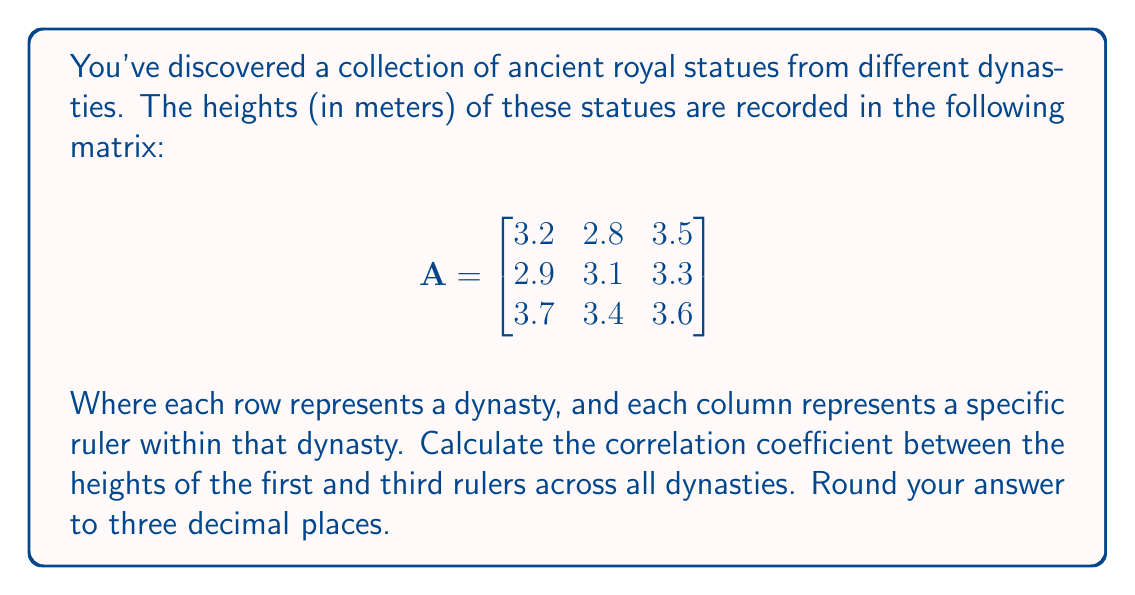Provide a solution to this math problem. To calculate the correlation coefficient between the heights of the first and third rulers, we'll follow these steps:

1) First, we need to extract the relevant columns from the matrix:

   First ruler (x): $[3.2, 2.9, 3.7]$
   Third ruler (y): $[3.5, 3.3, 3.6]$

2) Calculate the means:
   
   $\bar{x} = \frac{3.2 + 2.9 + 3.7}{3} = 3.267$
   $\bar{y} = \frac{3.5 + 3.3 + 3.6}{3} = 3.467$

3) Calculate the deviations from the mean:

   $x - \bar{x}: [-0.067, -0.367, 0.433]$
   $y - \bar{y}: [0.033, -0.167, 0.133]$

4) Calculate the products of the deviations:

   $(x - \bar{x})(y - \bar{y}): [-0.002211, 0.061289, 0.057589]$

5) Sum these products to get the covariance:

   $\text{cov}(x,y) = \frac{1}{n-1}\sum(x - \bar{x})(y - \bar{y}) = \frac{-0.002211 + 0.061289 + 0.057589}{2} = 0.0583335$

6) Calculate the standard deviations:

   $s_x = \sqrt{\frac{1}{n-1}\sum(x - \bar{x})^2} = \sqrt{\frac{(-0.067)^2 + (-0.367)^2 + (0.433)^2}{2}} = 0.4041$
   
   $s_y = \sqrt{\frac{1}{n-1}\sum(y - \bar{y})^2} = \sqrt{\frac{(0.033)^2 + (-0.167)^2 + (0.133)^2}{2}} = 0.1528$

7) Finally, calculate the correlation coefficient:

   $r = \frac{\text{cov}(x,y)}{s_x s_y} = \frac{0.0583335}{0.4041 * 0.1528} = 0.9437$

Rounded to three decimal places, this gives 0.944.
Answer: 0.944 